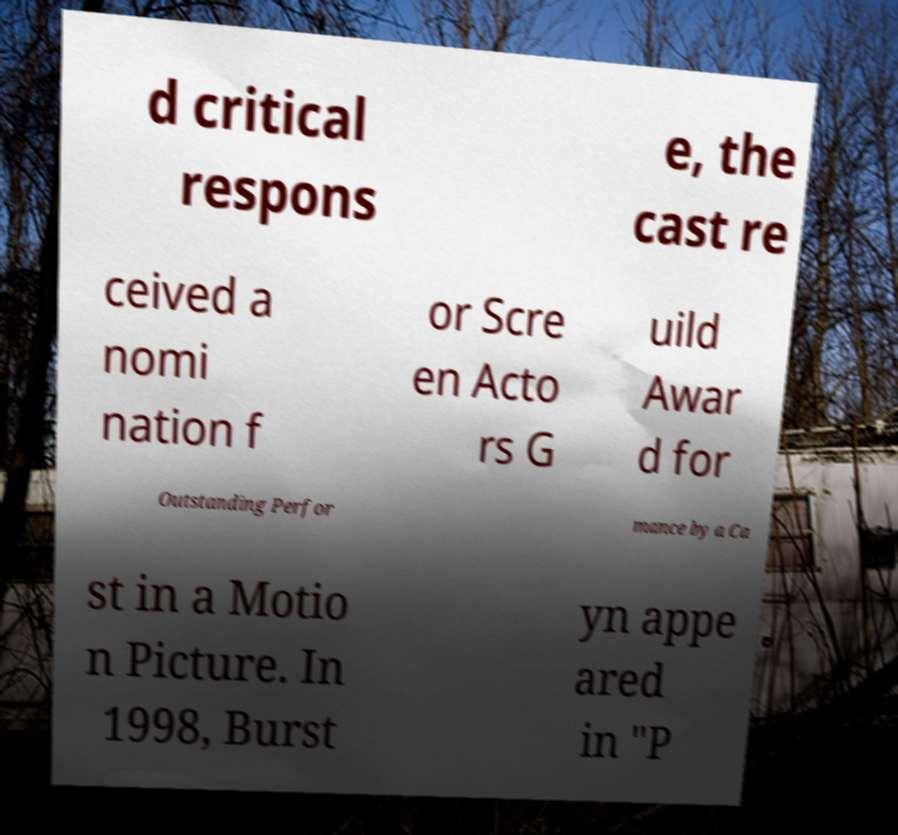I need the written content from this picture converted into text. Can you do that? d critical respons e, the cast re ceived a nomi nation f or Scre en Acto rs G uild Awar d for Outstanding Perfor mance by a Ca st in a Motio n Picture. In 1998, Burst yn appe ared in "P 